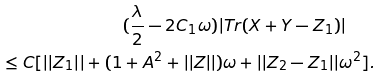Convert formula to latex. <formula><loc_0><loc_0><loc_500><loc_500>( \frac { \lambda } { 2 } - 2 C _ { 1 } \omega ) | T r ( X + Y - Z _ { 1 } ) | \quad \\ \leq C [ | | Z _ { 1 } | | + ( 1 + A ^ { 2 } + | | Z | | ) \omega + | | Z _ { 2 } - Z _ { 1 } | | \omega ^ { 2 } ] .</formula> 